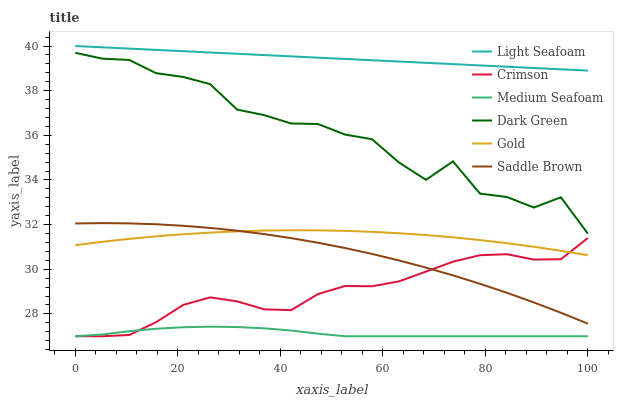Does Medium Seafoam have the minimum area under the curve?
Answer yes or no. Yes. Does Light Seafoam have the maximum area under the curve?
Answer yes or no. Yes. Does Crimson have the minimum area under the curve?
Answer yes or no. No. Does Crimson have the maximum area under the curve?
Answer yes or no. No. Is Light Seafoam the smoothest?
Answer yes or no. Yes. Is Dark Green the roughest?
Answer yes or no. Yes. Is Medium Seafoam the smoothest?
Answer yes or no. No. Is Medium Seafoam the roughest?
Answer yes or no. No. Does Medium Seafoam have the lowest value?
Answer yes or no. Yes. Does Light Seafoam have the lowest value?
Answer yes or no. No. Does Light Seafoam have the highest value?
Answer yes or no. Yes. Does Crimson have the highest value?
Answer yes or no. No. Is Medium Seafoam less than Gold?
Answer yes or no. Yes. Is Saddle Brown greater than Medium Seafoam?
Answer yes or no. Yes. Does Saddle Brown intersect Gold?
Answer yes or no. Yes. Is Saddle Brown less than Gold?
Answer yes or no. No. Is Saddle Brown greater than Gold?
Answer yes or no. No. Does Medium Seafoam intersect Gold?
Answer yes or no. No. 